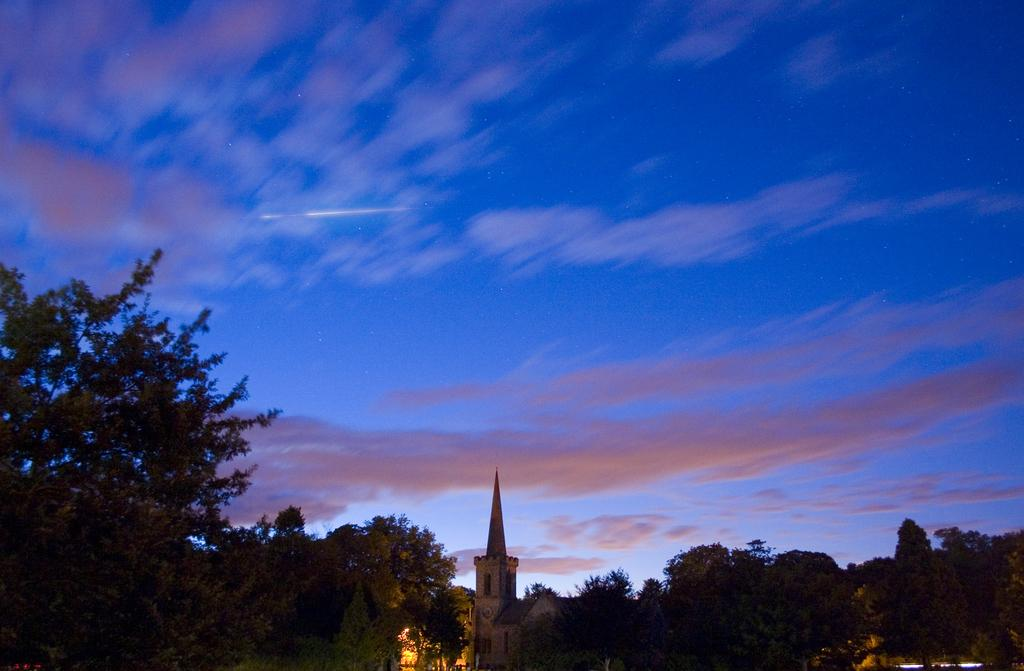What type of structure is visible in the image? There is a building in the image. What other natural elements can be seen in the image? There are trees in the image. How would you describe the weather based on the sky in the image? The sky is cloudy in the image. How many ducks are present in the image? There are no ducks present in the image. What is the result of the division operation in the image? There is no division operation present in the image. 